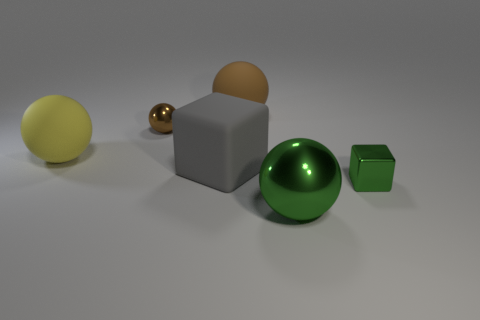Subtract all green balls. How many balls are left? 3 Add 1 small green matte spheres. How many objects exist? 7 Subtract 3 balls. How many balls are left? 1 Subtract all large gray cubes. Subtract all green shiny things. How many objects are left? 3 Add 6 big green objects. How many big green objects are left? 7 Add 2 large matte things. How many large matte things exist? 5 Subtract all green cubes. How many cubes are left? 1 Subtract 1 green spheres. How many objects are left? 5 Subtract all balls. How many objects are left? 2 Subtract all cyan cubes. Subtract all brown cylinders. How many cubes are left? 2 